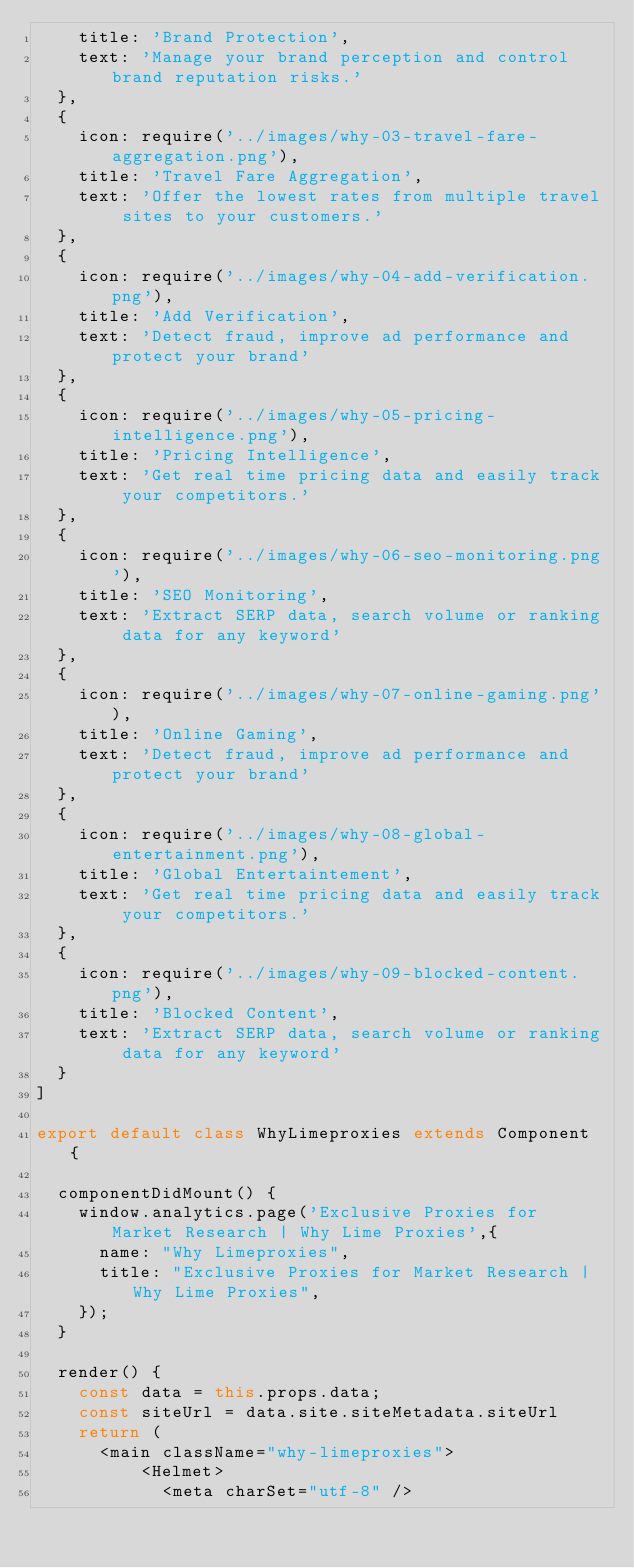Convert code to text. <code><loc_0><loc_0><loc_500><loc_500><_JavaScript_>    title: 'Brand Protection',
    text: 'Manage your brand perception and control brand reputation risks.'
  },
  {
    icon: require('../images/why-03-travel-fare-aggregation.png'),
    title: 'Travel Fare Aggregation',
    text: 'Offer the lowest rates from multiple travel sites to your customers.'
  },
  {
    icon: require('../images/why-04-add-verification.png'),
    title: 'Add Verification',
    text: 'Detect fraud, improve ad performance and protect your brand'
  },
  {
    icon: require('../images/why-05-pricing-intelligence.png'),
    title: 'Pricing Intelligence',
    text: 'Get real time pricing data and easily track your competitors.'
  },
  {
    icon: require('../images/why-06-seo-monitoring.png'),
    title: 'SEO Monitoring',
    text: 'Extract SERP data, search volume or ranking data for any keyword'
  },
  {
    icon: require('../images/why-07-online-gaming.png'),
    title: 'Online Gaming',
    text: 'Detect fraud, improve ad performance and protect your brand'
  },
  {
    icon: require('../images/why-08-global-entertainment.png'),
    title: 'Global Entertaintement',
    text: 'Get real time pricing data and easily track your competitors.'
  },
  {
    icon: require('../images/why-09-blocked-content.png'),
    title: 'Blocked Content',
    text: 'Extract SERP data, search volume or ranking data for any keyword'
  }
]

export default class WhyLimeproxies extends Component {

  componentDidMount() {
    window.analytics.page('Exclusive Proxies for Market Research | Why Lime Proxies',{
      name: "Why Limeproxies",
      title: "Exclusive Proxies for Market Research | Why Lime Proxies",
    });
  }

  render() {
    const data = this.props.data;
    const siteUrl = data.site.siteMetadata.siteUrl
    return (
      <main className="why-limeproxies">
          <Helmet>
            <meta charSet="utf-8" /></code> 